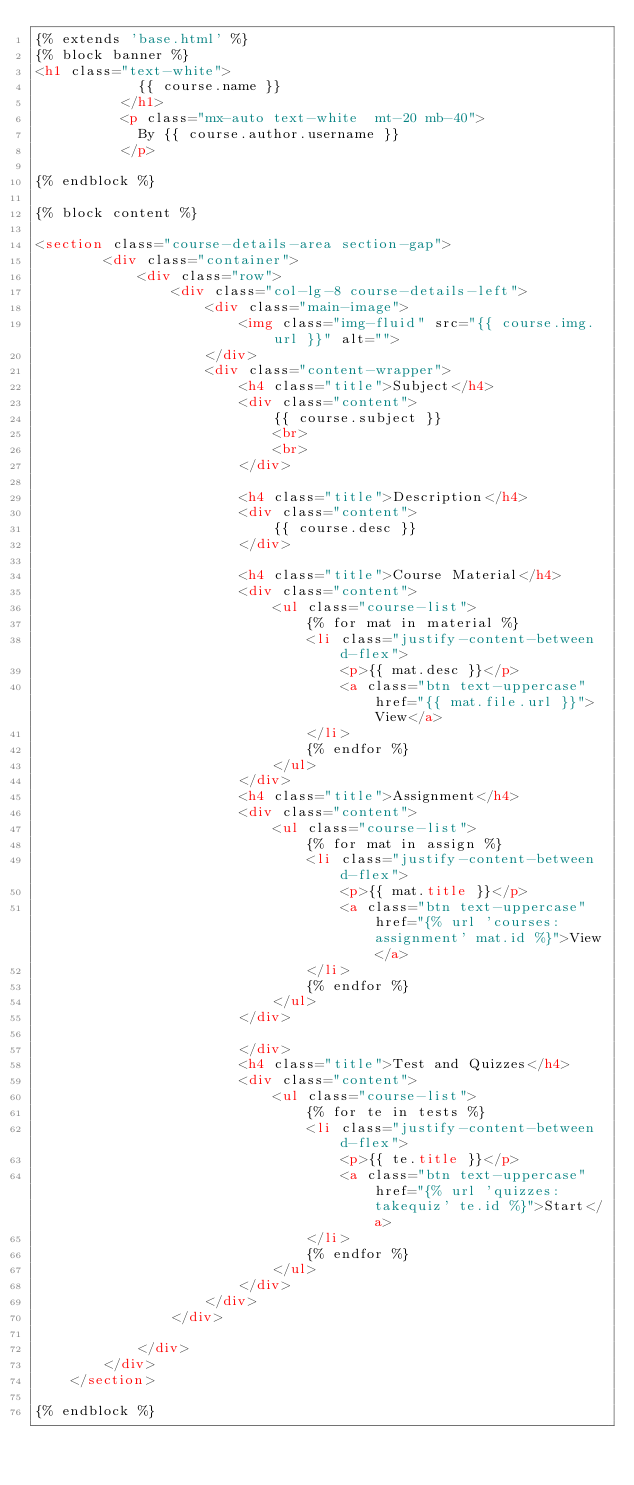Convert code to text. <code><loc_0><loc_0><loc_500><loc_500><_HTML_>{% extends 'base.html' %}
{% block banner %}
<h1 class="text-white">
            {{ course.name }}
          </h1>
          <p class="mx-auto text-white  mt-20 mb-40">
            By {{ course.author.username }}
          </p>

{% endblock %}

{% block content %}

<section class="course-details-area section-gap">
        <div class="container">
            <div class="row">
                <div class="col-lg-8 course-details-left">
                    <div class="main-image">
                        <img class="img-fluid" src="{{ course.img.url }}" alt="">
                    </div>
                    <div class="content-wrapper">
                        <h4 class="title">Subject</h4>
                        <div class="content">
                            {{ course.subject }}
                            <br>
                            <br>
                        </div>

                        <h4 class="title">Description</h4>
                        <div class="content">
                            {{ course.desc }}
                        </div>

                        <h4 class="title">Course Material</h4>
                        <div class="content">
                            <ul class="course-list">
                                {% for mat in material %}
                                <li class="justify-content-between d-flex">
                                    <p>{{ mat.desc }}</p>
                                    <a class="btn text-uppercase" href="{{ mat.file.url }}">View</a>
                                </li>
                                {% endfor %}
                            </ul>
                        </div>
                        <h4 class="title">Assignment</h4>
                        <div class="content">
                            <ul class="course-list">
                                {% for mat in assign %}
                                <li class="justify-content-between d-flex">
                                    <p>{{ mat.title }}</p>
                                    <a class="btn text-uppercase" href="{% url 'courses:assignment' mat.id %}">View</a>
                                </li>
                                {% endfor %}
                            </ul>
                        </div>

                        </div>
                        <h4 class="title">Test and Quizzes</h4>
                        <div class="content">
                            <ul class="course-list">
                                {% for te in tests %}
                                <li class="justify-content-between d-flex">
                                    <p>{{ te.title }}</p>
                                    <a class="btn text-uppercase" href="{% url 'quizzes:takequiz' te.id %}">Start</a>
                                </li>
                                {% endfor %}
                            </ul>
                        </div>
                    </div>
                </div>

            </div>
        </div>
    </section>

{% endblock %}</code> 